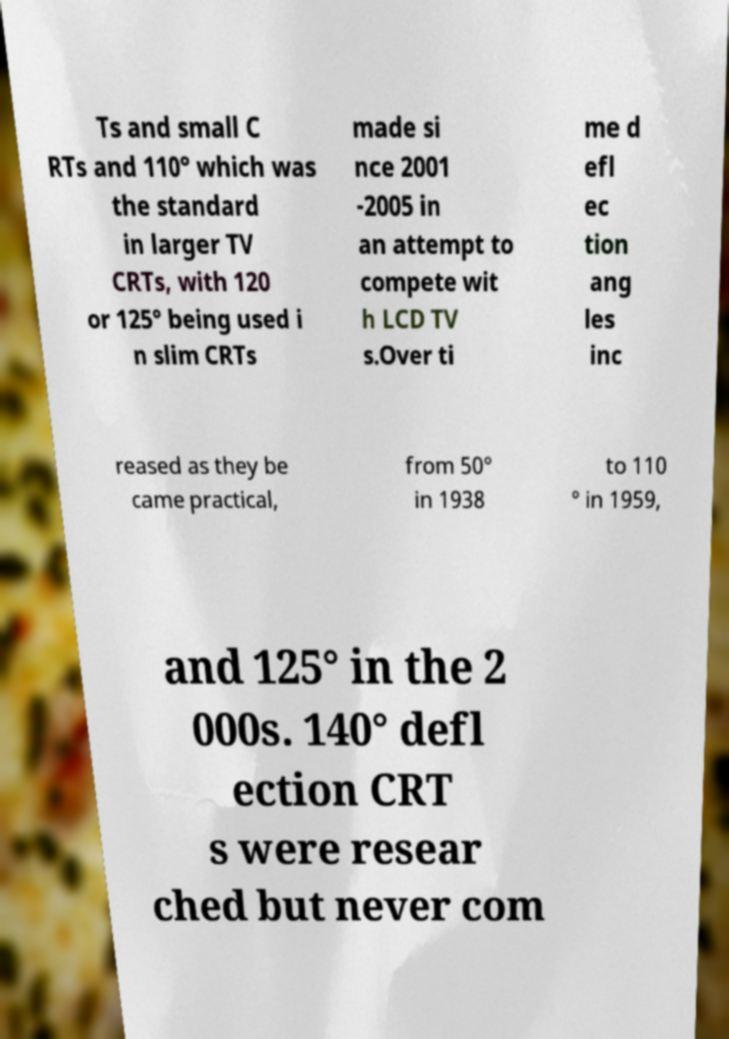Can you read and provide the text displayed in the image?This photo seems to have some interesting text. Can you extract and type it out for me? Ts and small C RTs and 110° which was the standard in larger TV CRTs, with 120 or 125° being used i n slim CRTs made si nce 2001 -2005 in an attempt to compete wit h LCD TV s.Over ti me d efl ec tion ang les inc reased as they be came practical, from 50° in 1938 to 110 ° in 1959, and 125° in the 2 000s. 140° defl ection CRT s were resear ched but never com 